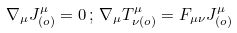<formula> <loc_0><loc_0><loc_500><loc_500>\nabla _ { \mu } J ^ { \mu } _ { ( o ) } = 0 \, ; \, \nabla _ { \mu } T ^ { \mu } _ { \nu ( o ) } = F _ { \mu \nu } J ^ { \mu } _ { ( o ) }</formula> 